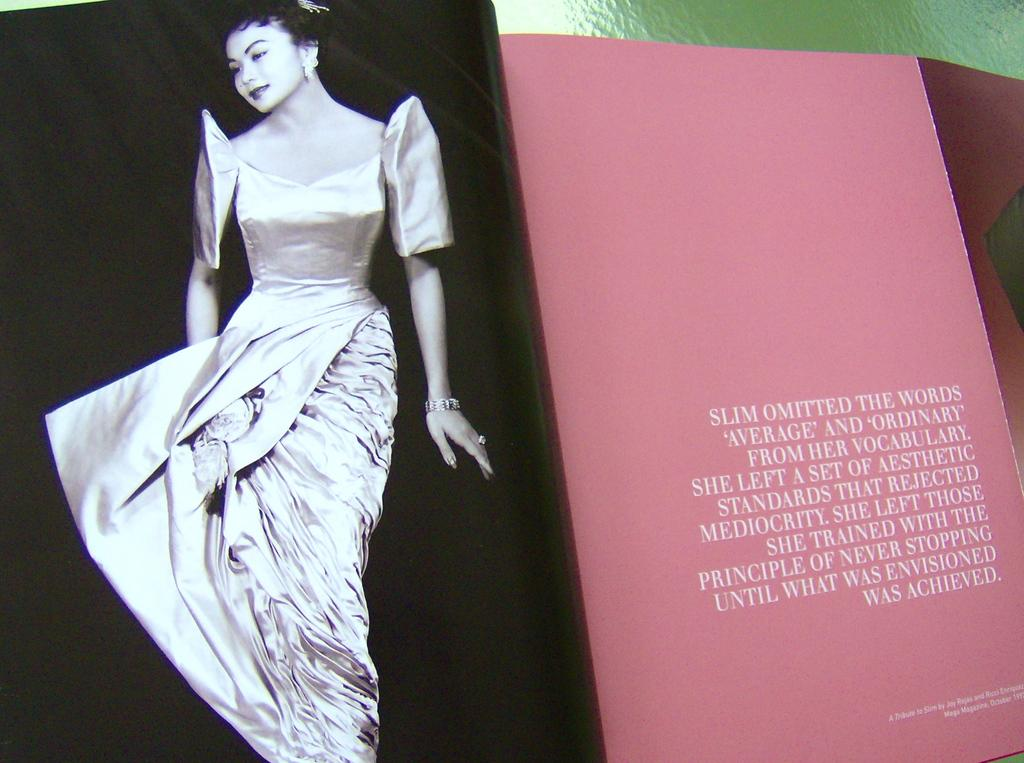<image>
Offer a succinct explanation of the picture presented. the word slim is in a book that is pink 